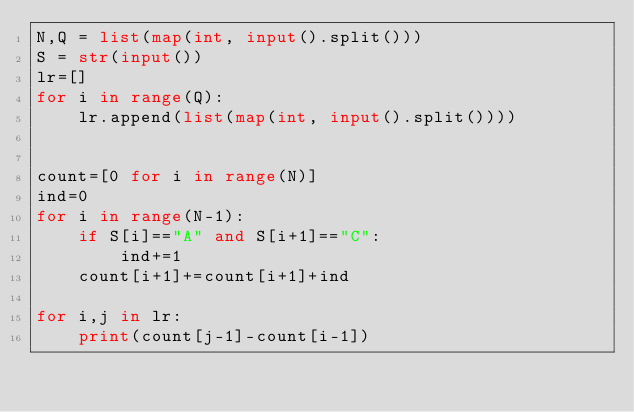<code> <loc_0><loc_0><loc_500><loc_500><_Python_>N,Q = list(map(int, input().split()))
S = str(input())
lr=[]
for i in range(Q):
    lr.append(list(map(int, input().split())))


count=[0 for i in range(N)]
ind=0
for i in range(N-1):
    if S[i]=="A" and S[i+1]=="C":
        ind+=1
    count[i+1]+=count[i+1]+ind

for i,j in lr:
    print(count[j-1]-count[i-1])

</code> 